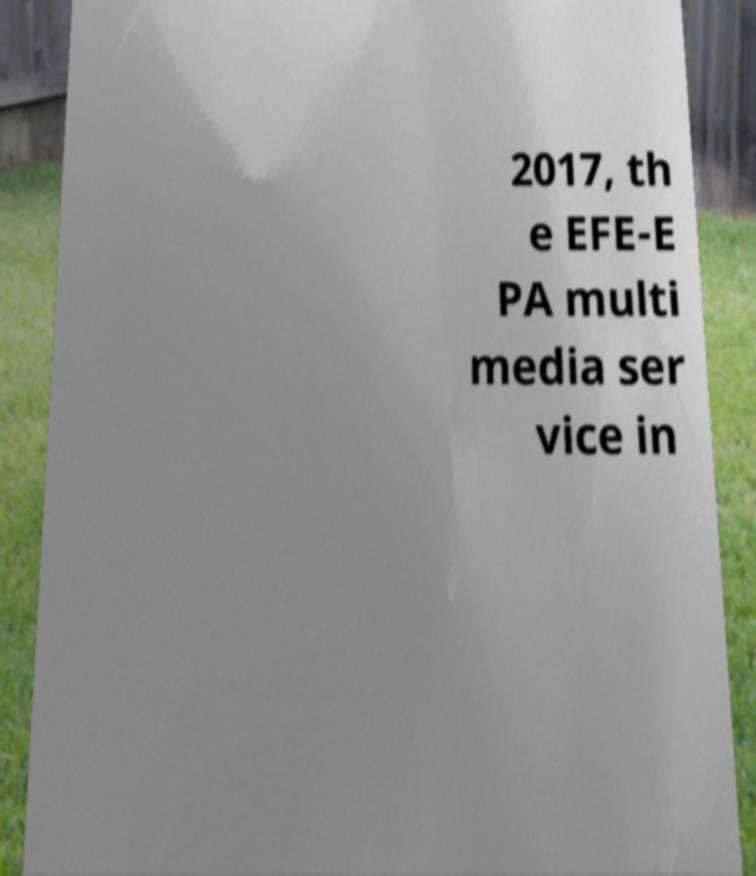What messages or text are displayed in this image? I need them in a readable, typed format. 2017, th e EFE-E PA multi media ser vice in 